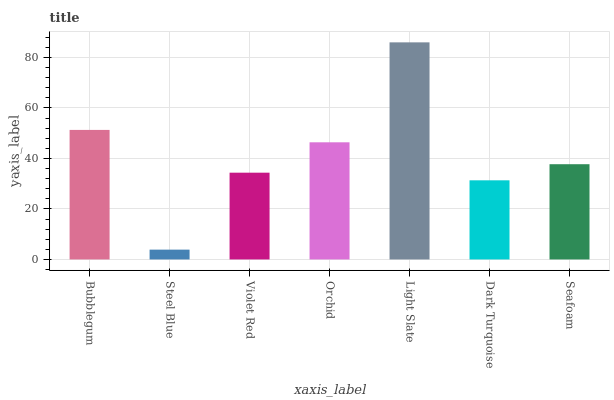Is Steel Blue the minimum?
Answer yes or no. Yes. Is Light Slate the maximum?
Answer yes or no. Yes. Is Violet Red the minimum?
Answer yes or no. No. Is Violet Red the maximum?
Answer yes or no. No. Is Violet Red greater than Steel Blue?
Answer yes or no. Yes. Is Steel Blue less than Violet Red?
Answer yes or no. Yes. Is Steel Blue greater than Violet Red?
Answer yes or no. No. Is Violet Red less than Steel Blue?
Answer yes or no. No. Is Seafoam the high median?
Answer yes or no. Yes. Is Seafoam the low median?
Answer yes or no. Yes. Is Dark Turquoise the high median?
Answer yes or no. No. Is Bubblegum the low median?
Answer yes or no. No. 